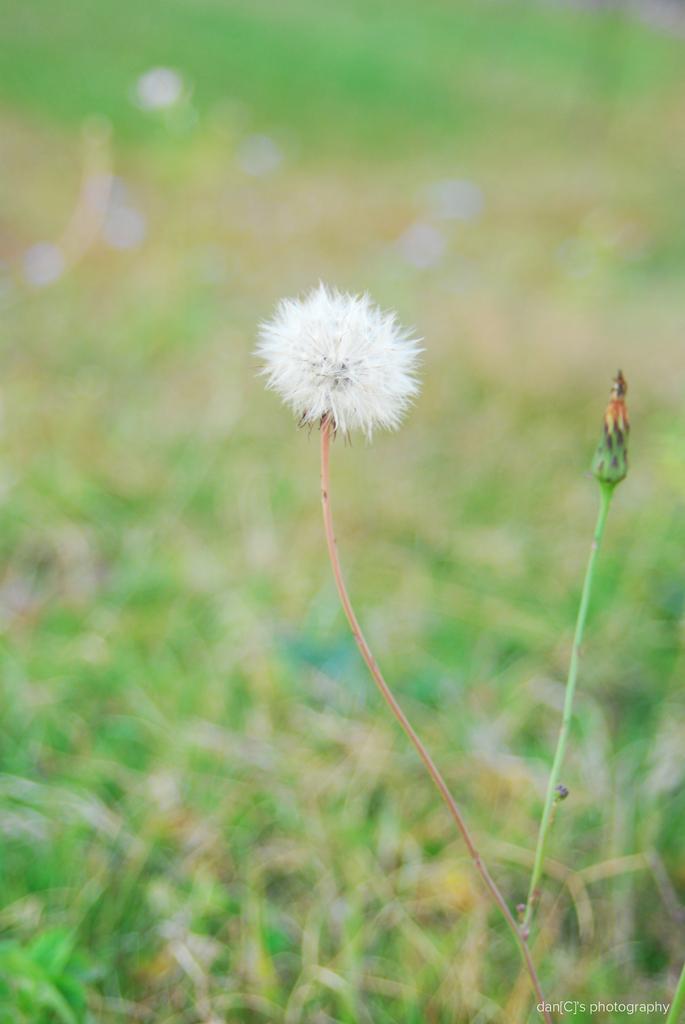Please provide a concise description of this image. In this image we can see a white color flower with stem. 